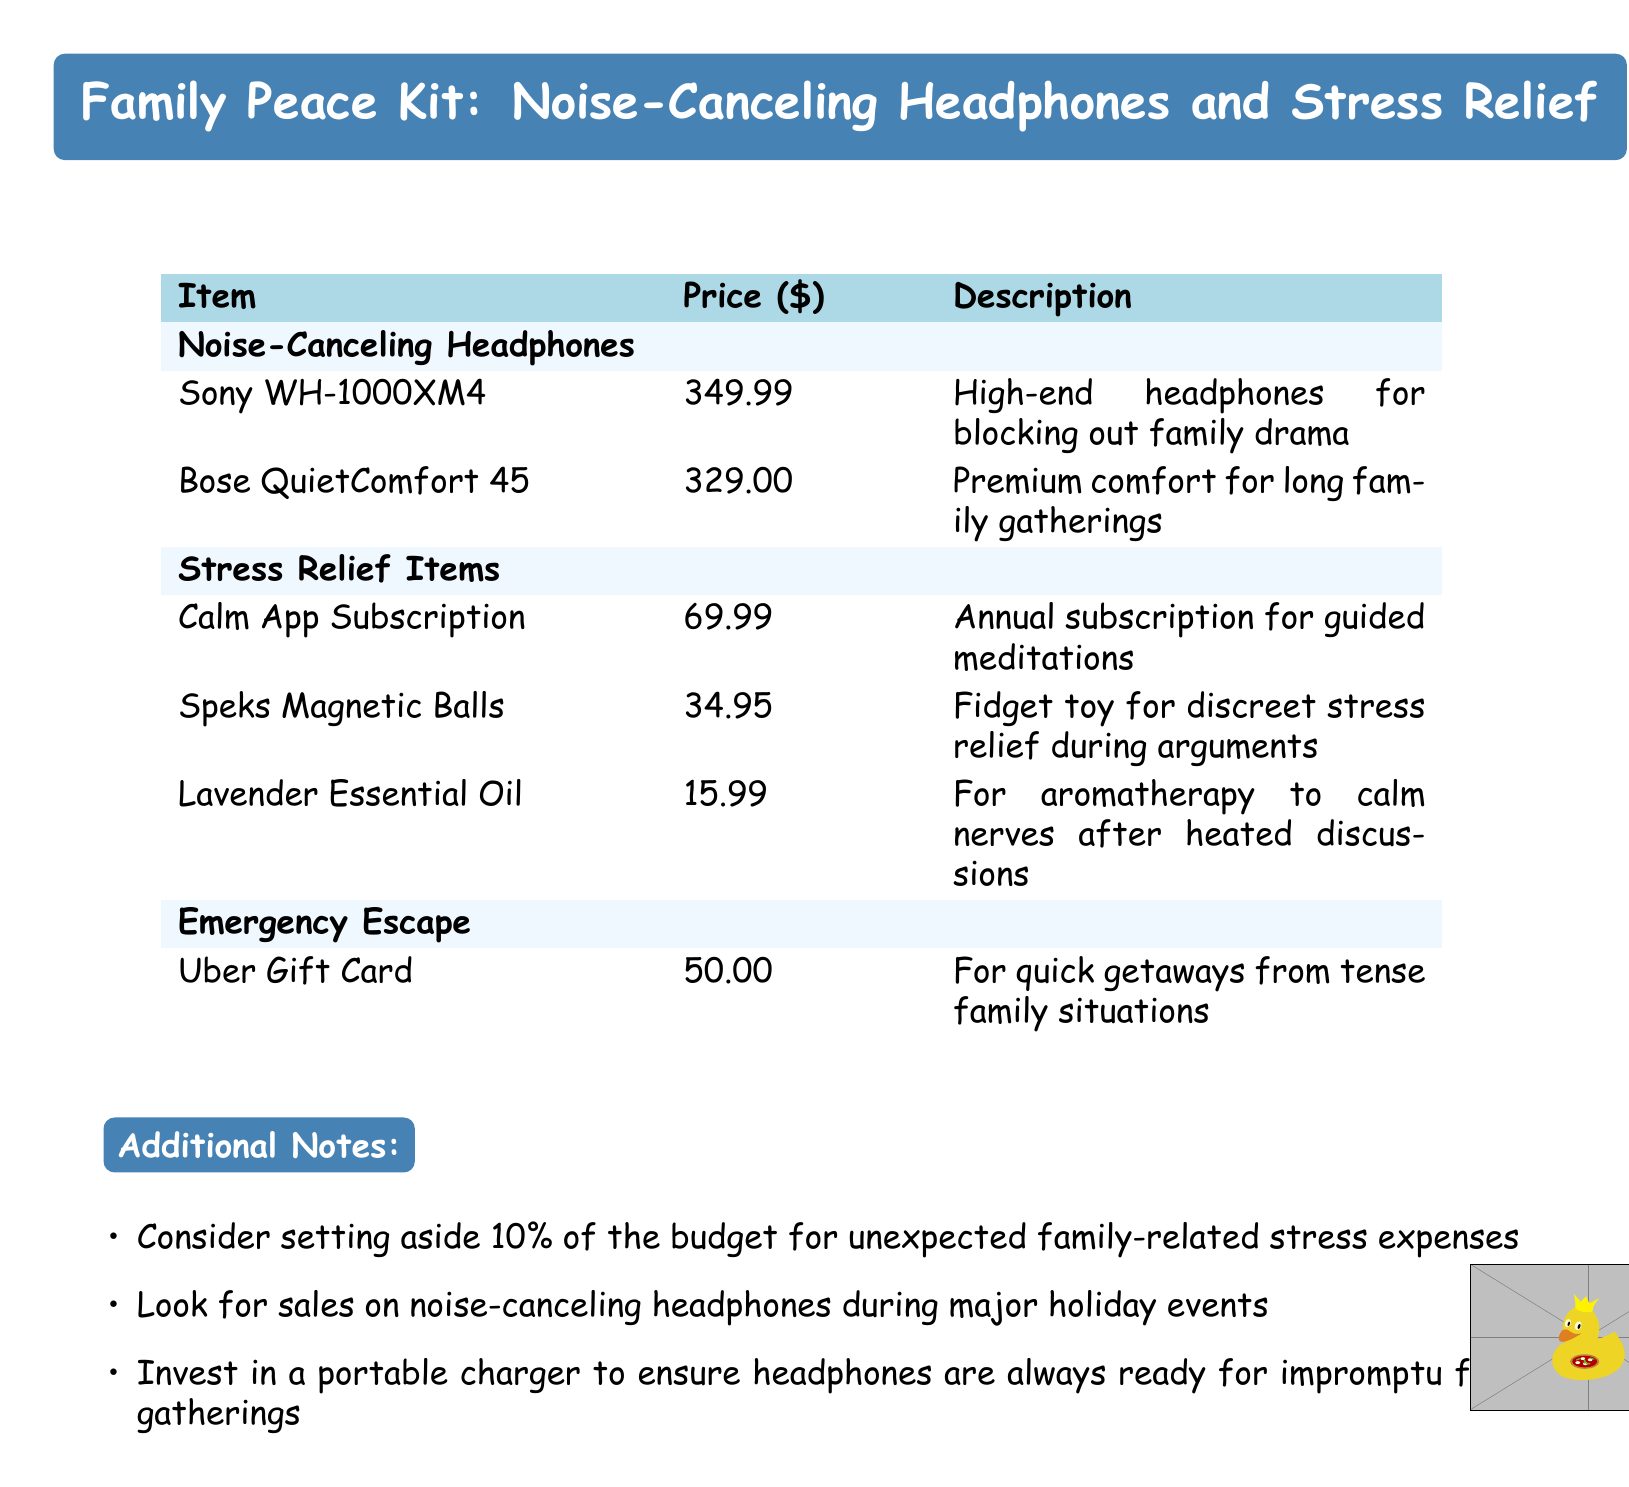What is the price of Sony WH-1000XM4? The price of Sony WH-1000XM4 is specified in the document under the noise-canceling headphones section.
Answer: 349.99 What type of item is Lavender Essential Oil? Lavender Essential Oil is categorized under stress relief items in the document.
Answer: Stress Relief Item How much is the Calm App Subscription? The document lists the Calm App Subscription cost, which is found in the stress relief items section.
Answer: 69.99 What percentage of the budget is recommended for unexpected expenses? The document suggests setting aside a portion of the budget for unforeseen expenses, which is given as a percentage.
Answer: 10% Which item is meant for quick getaways from tense family situations? The document specifies an item under the emergency escape section that serves this purpose.
Answer: Uber Gift Card What is the total cost of the two noise-canceling headphones listed? The total cost is the sum of both headphone prices provided in the document.
Answer: 678.99 How many stress relief items are listed in the document? To answer this, one counts the items categorized under stress relief in the document.
Answer: Three What color is used for the table head in the document? The document describes the color used for the table head and it is mentioned explicitly.
Answer: Light Blue 